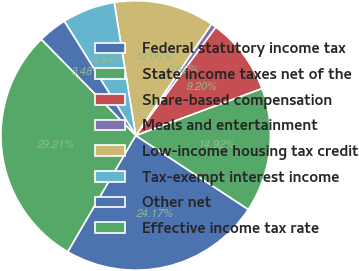Convert chart to OTSL. <chart><loc_0><loc_0><loc_500><loc_500><pie_chart><fcel>Federal statutory income tax<fcel>State income taxes net of the<fcel>Share-based compensation<fcel>Meals and entertainment<fcel>Low-income housing tax credit<fcel>Tax-exempt interest income<fcel>Other net<fcel>Effective income tax rate<nl><fcel>24.17%<fcel>14.92%<fcel>9.2%<fcel>0.62%<fcel>12.06%<fcel>6.34%<fcel>3.48%<fcel>29.21%<nl></chart> 